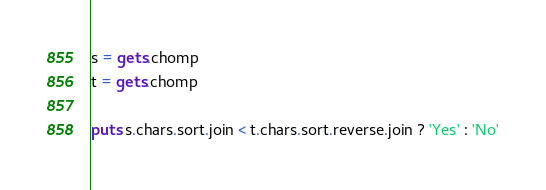Convert code to text. <code><loc_0><loc_0><loc_500><loc_500><_Ruby_>s = gets.chomp
t = gets.chomp

puts s.chars.sort.join < t.chars.sort.reverse.join ? 'Yes' : 'No'</code> 